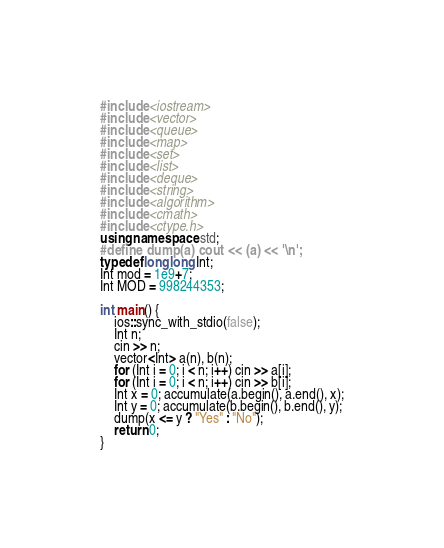Convert code to text. <code><loc_0><loc_0><loc_500><loc_500><_C++_>#include <iostream>
#include <vector>
#include <queue>
#include <map>
#include <set>
#include <list>
#include <deque>
#include <string>
#include <algorithm>
#include <cmath>
#include <ctype.h>
using namespace std;
#define dump(a) cout << (a) << '\n';
typedef long long Int;
Int mod = 1e9+7;
Int MOD = 998244353;

int main() {
    ios::sync_with_stdio(false);
    Int n;
    cin >> n;
    vector<Int> a(n), b(n);
    for (Int i = 0; i < n; i++) cin >> a[i];
    for (Int i = 0; i < n; i++) cin >> b[i];
    Int x = 0; accumulate(a.begin(), a.end(), x);
    Int y = 0; accumulate(b.begin(), b.end(), y);
    dump(x <= y ? "Yes" : "No");
    return 0;  
}</code> 